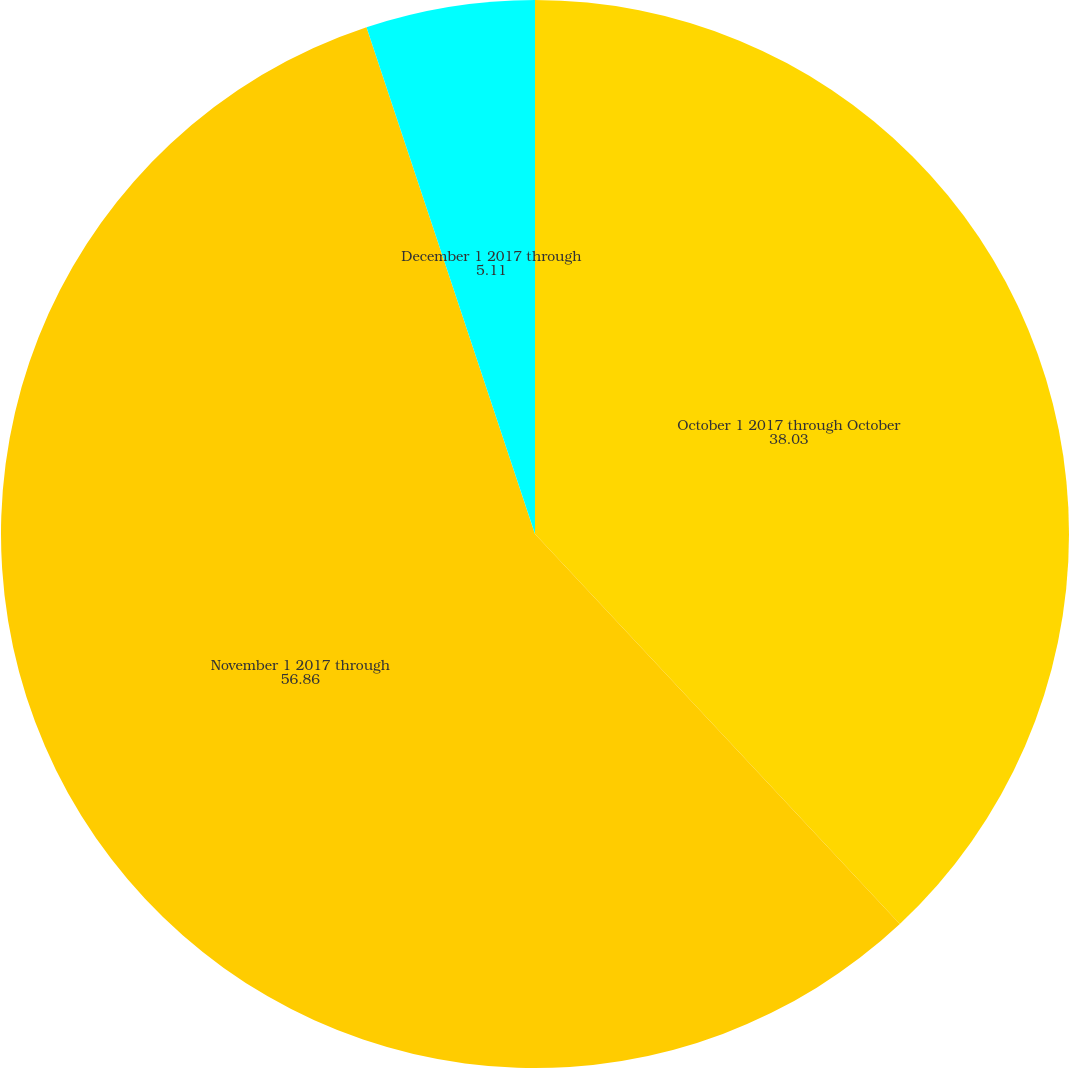Convert chart. <chart><loc_0><loc_0><loc_500><loc_500><pie_chart><fcel>October 1 2017 through October<fcel>November 1 2017 through<fcel>December 1 2017 through<nl><fcel>38.03%<fcel>56.86%<fcel>5.11%<nl></chart> 